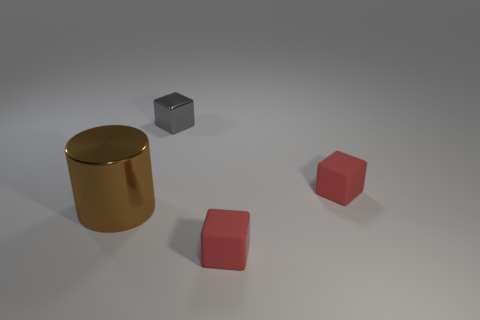How many things are either small blocks in front of the large metallic thing or brown shiny cylinders?
Ensure brevity in your answer.  2. What is the color of the matte block that is behind the red matte object that is in front of the metal object that is to the left of the tiny metal thing?
Give a very brief answer. Red. There is a thing that is made of the same material as the big cylinder; what is its color?
Provide a short and direct response. Gray. What number of tiny objects are the same material as the brown cylinder?
Make the answer very short. 1. There is a metallic object that is in front of the gray thing; is its size the same as the tiny gray object?
Make the answer very short. No. How many gray metal blocks are on the right side of the tiny metal thing?
Keep it short and to the point. 0. Are any gray blocks visible?
Give a very brief answer. Yes. What size is the red matte object that is on the right side of the small red cube that is left of the small matte cube that is behind the big cylinder?
Keep it short and to the point. Small. How many other objects are the same size as the gray block?
Make the answer very short. 2. What is the size of the red rubber cube that is behind the brown thing?
Your response must be concise. Small. 